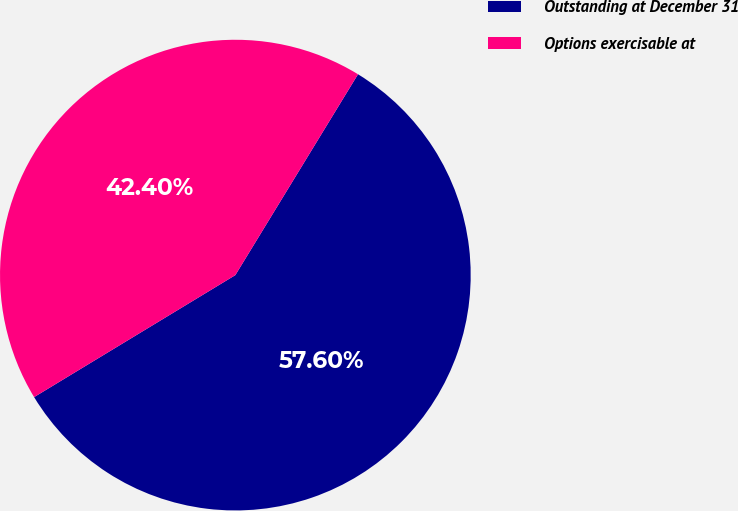Convert chart. <chart><loc_0><loc_0><loc_500><loc_500><pie_chart><fcel>Outstanding at December 31<fcel>Options exercisable at<nl><fcel>57.6%<fcel>42.4%<nl></chart> 